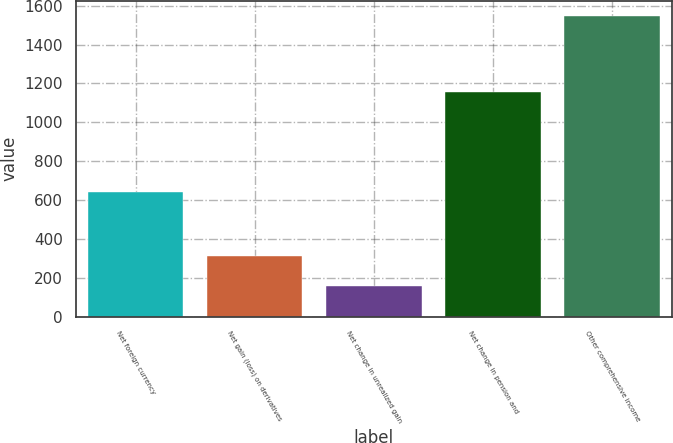Convert chart to OTSL. <chart><loc_0><loc_0><loc_500><loc_500><bar_chart><fcel>Net foreign currency<fcel>Net gain (loss) on derivatives<fcel>Net change in unrealized gain<fcel>Net change in pension and<fcel>Other comprehensive income<nl><fcel>639<fcel>314.6<fcel>160.3<fcel>1156<fcel>1549<nl></chart> 